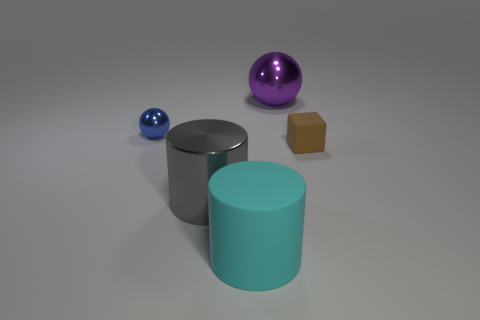There is a thing that is in front of the large purple shiny ball and behind the small brown rubber thing; what color is it?
Give a very brief answer. Blue. How many cylinders are either large rubber things or large gray metal objects?
Your answer should be very brief. 2. There is a matte object in front of the brown matte object; what is its shape?
Offer a very short reply. Cylinder. What color is the tiny thing that is behind the small object to the right of the big cylinder in front of the large gray metallic cylinder?
Keep it short and to the point. Blue. Are the small brown object and the tiny sphere made of the same material?
Offer a terse response. No. What number of purple objects are either big metallic objects or shiny spheres?
Provide a succinct answer. 1. How many big matte things are behind the gray cylinder?
Your response must be concise. 0. Is the number of matte cubes greater than the number of red shiny cubes?
Your answer should be very brief. Yes. What shape is the tiny object behind the matte object on the right side of the cyan thing?
Give a very brief answer. Sphere. Do the large metal cylinder and the block have the same color?
Offer a terse response. No. 